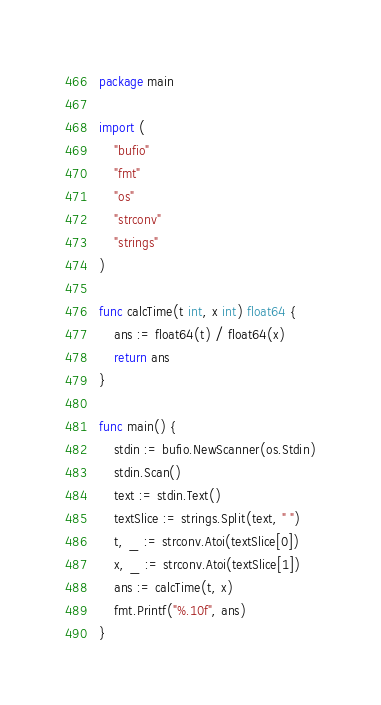Convert code to text. <code><loc_0><loc_0><loc_500><loc_500><_Go_>package main

import (
	"bufio"
	"fmt"
	"os"
	"strconv"
	"strings"
)

func calcTime(t int, x int) float64 {
	ans := float64(t) / float64(x)
	return ans
}

func main() {
	stdin := bufio.NewScanner(os.Stdin)
	stdin.Scan()
	text := stdin.Text()
	textSlice := strings.Split(text, " ")
	t, _ := strconv.Atoi(textSlice[0])
	x, _ := strconv.Atoi(textSlice[1])
	ans := calcTime(t, x)
	fmt.Printf("%.10f", ans)
}
</code> 